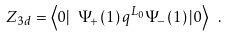<formula> <loc_0><loc_0><loc_500><loc_500>Z _ { 3 d } = \left \langle 0 | \text { } \Psi _ { + } \left ( 1 \right ) q ^ { L _ { 0 } } \Psi _ { - } \left ( 1 \right ) | 0 \right \rangle \text { } .</formula> 